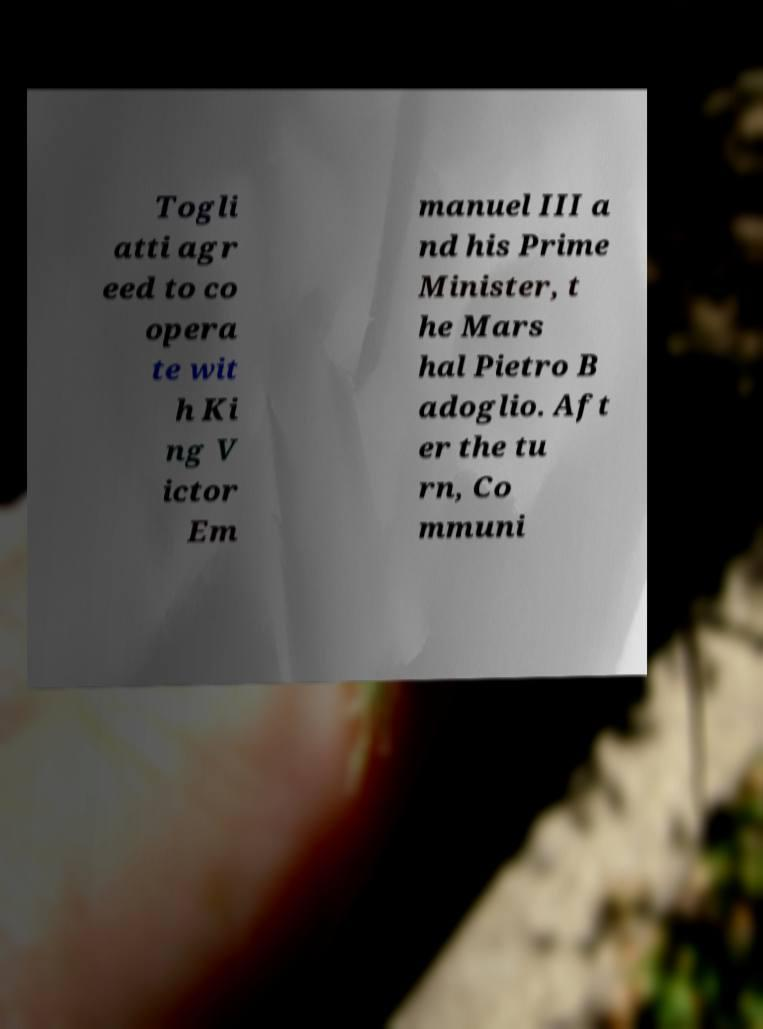Please read and relay the text visible in this image. What does it say? Togli atti agr eed to co opera te wit h Ki ng V ictor Em manuel III a nd his Prime Minister, t he Mars hal Pietro B adoglio. Aft er the tu rn, Co mmuni 